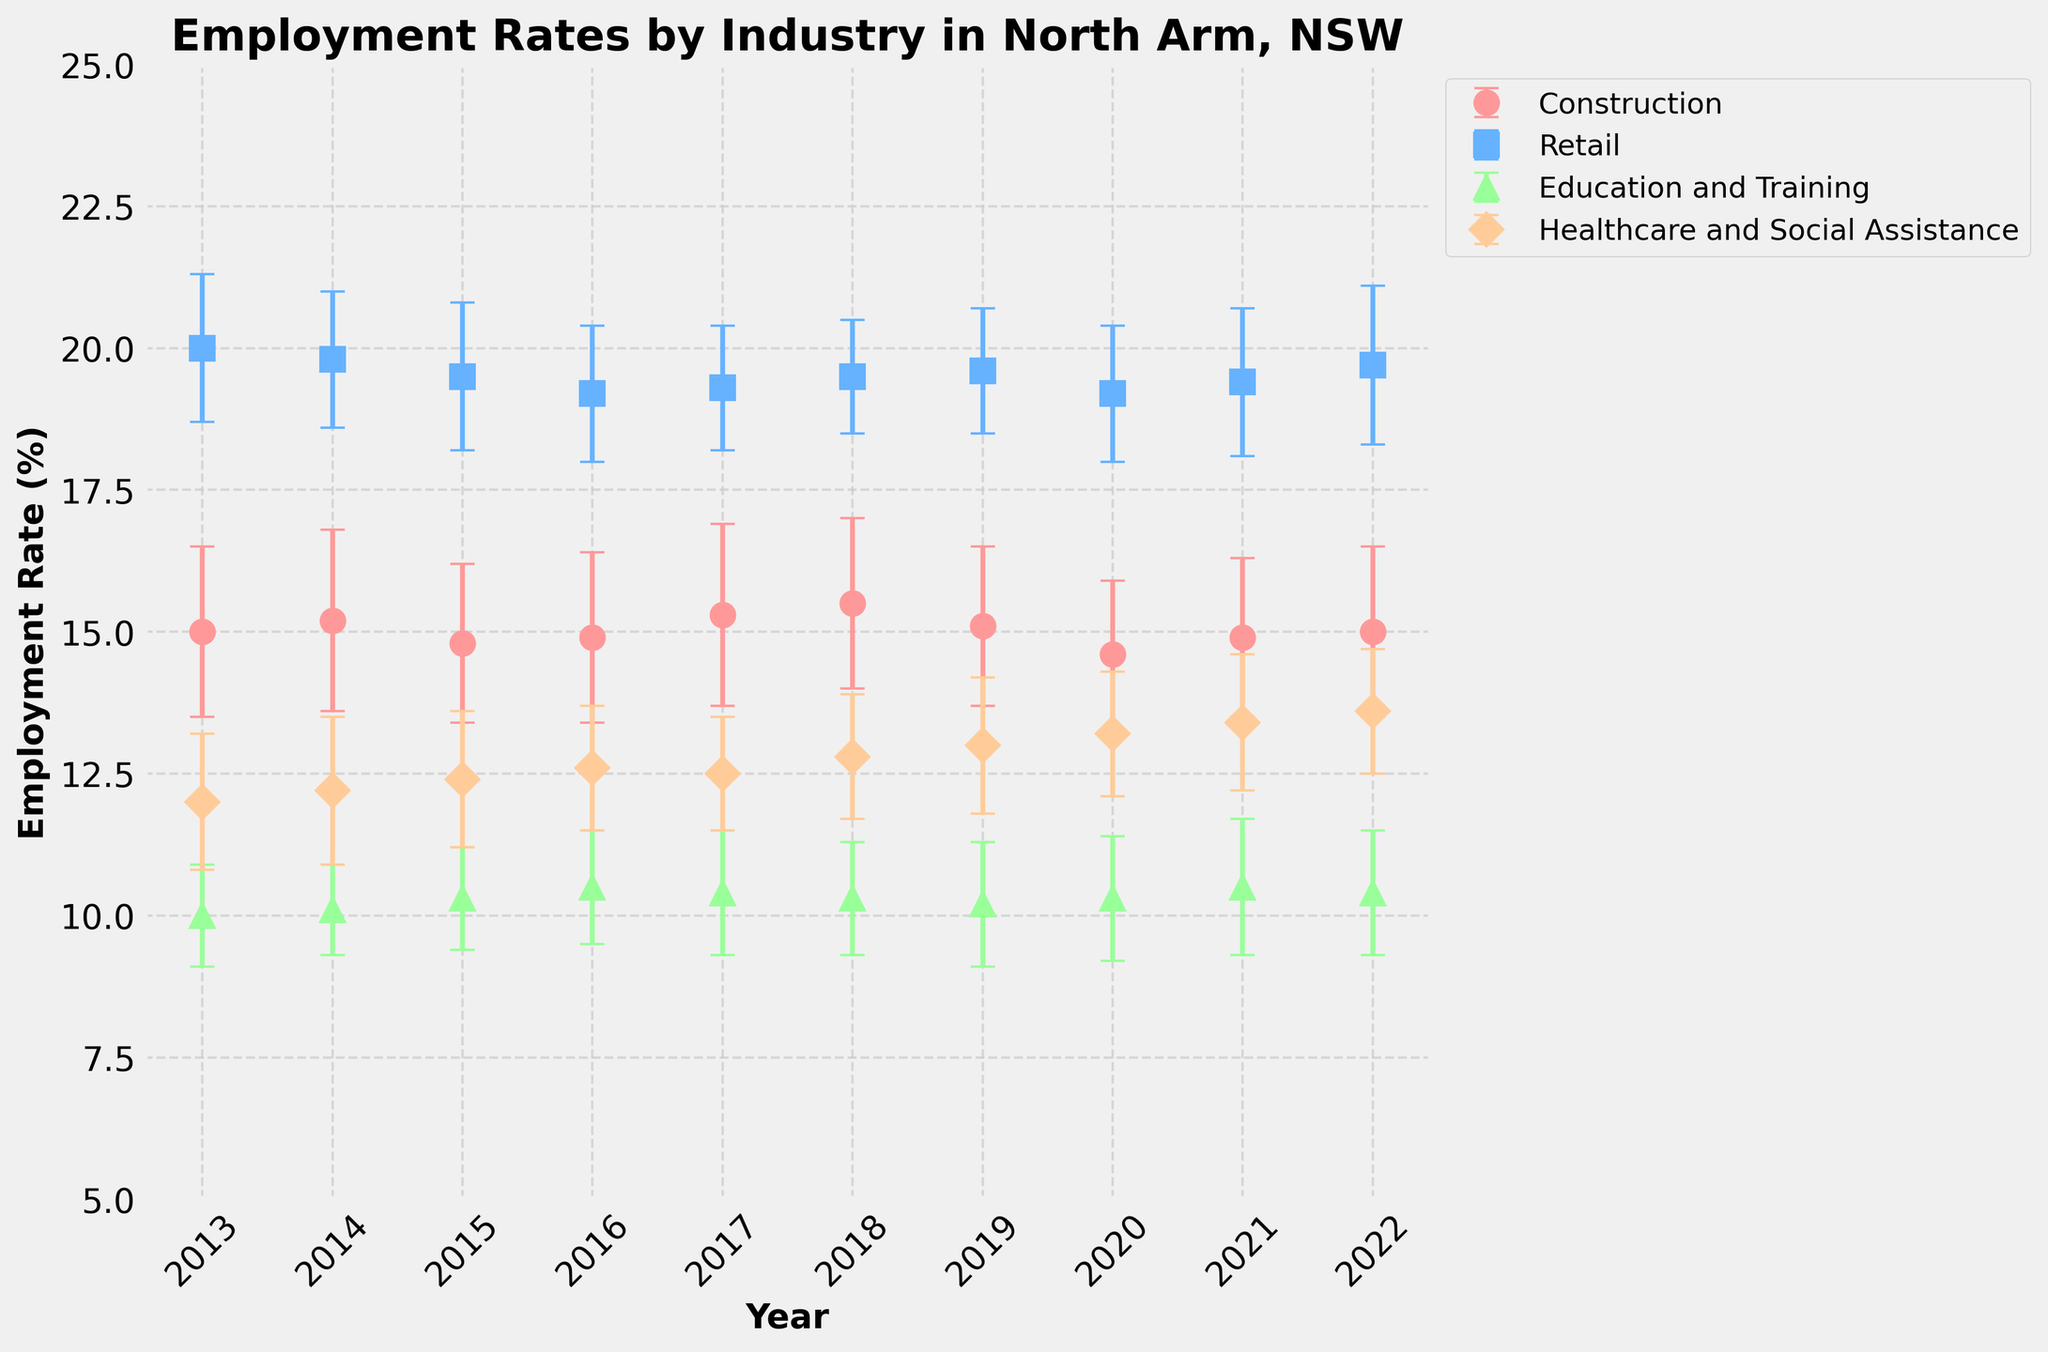What is the title of the figure? The figure's title is located at the top, usually in larger and bold font, used to summarize or describe the figure's content.
Answer: Employment Rates by Industry in North Arm, NSW How many industries are represented in the figure? Each color and marker type in the plot represent different industries. By counting the unique combinations, you can find the number of industries.
Answer: 4 Which industry had the highest employment rate in 2013? Look at the data points for 2013 and identify the industry with the highest value on the y-axis.
Answer: Retail In which year did the Construction industry have the lowest employment rate? Look at the data points for the Construction industry and identify the year with the lowest value on the y-axis.
Answer: 2020 What is the overall trend of the employment rate in the Healthcare and Social Assistance industry from 2013 to 2022? Observe the slope of the data points for the Healthcare and Social Assistance industry from left to right (2013 to 2022). The increasing or decreasing pattern indicates the trend.
Answer: Increasing Which industry shows the most variability (as indicated by the largest average error bars) over the years? Compare the height of the error bars (which represent standard error) for each industry's data points over time. Compute the average size of these error bars for each industry and identify the largest.
Answer: Retail In 2022, which industry showed the highest employment rate with the smallest standard error? Check the data points for 2022 and compare both the employment rates and the size of the error bars. Find the highest value with the smallest error range among them.
Answer: Retail How does the employment rate in Education and Training in 2022 compare to its rate in 2013? Compare the y-values of the data points for Education and Training in 2022 and 2013. Subtract the 2013 value from the 2022 value to determine the difference.
Answer: Increased by 0.4% Between 2017 and 2018, which industry experienced the largest absolute change in employment rate? Calculate the differences between the 2017 and 2018 data points for each industry and compare these differences to find the largest absolute change.
Answer: Construction Does any industry have overlapping error bars with another industry in 2022? Look at the 2022 data points and their associated error bars for each industry. Determine whether any error bars overlap vertically on the y-axis.
Answer: Yes 